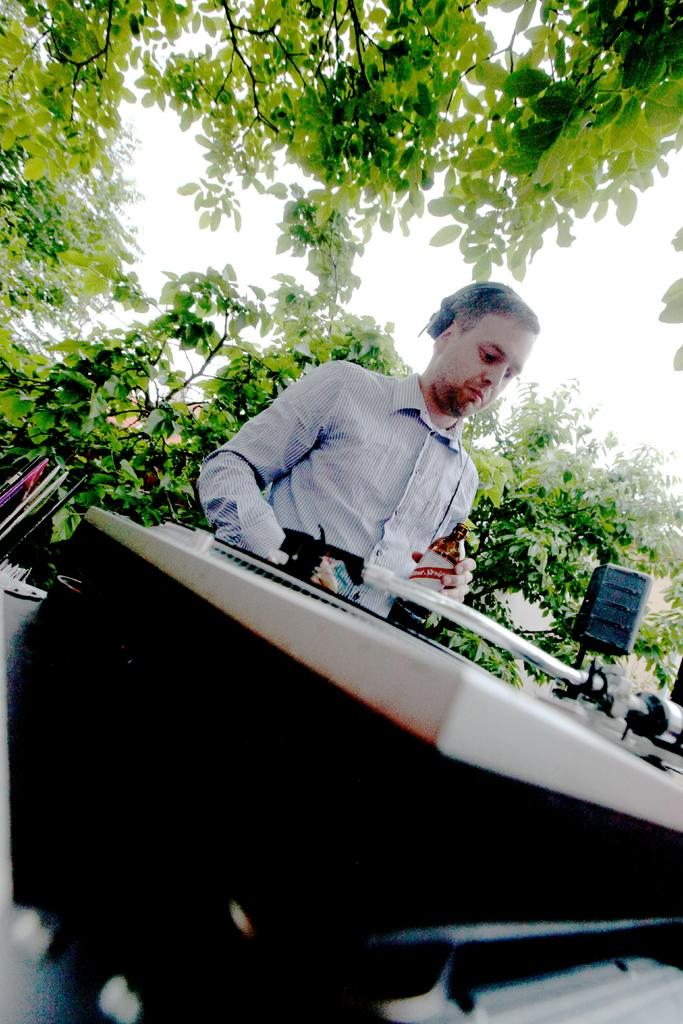What is the man in the image doing? The man is sitting in the image. What is the man holding in the image? The man is holding a bottle in the image. Can you describe the object in the image? Unfortunately, the provided facts do not give enough information to describe the object in the image. What type of vegetation can be seen in the image? There are trees with branches and leaves in the image. What type of zebra can be seen teaching the man in the image? There is no zebra present in the image, and the man is not being taught by anyone. 